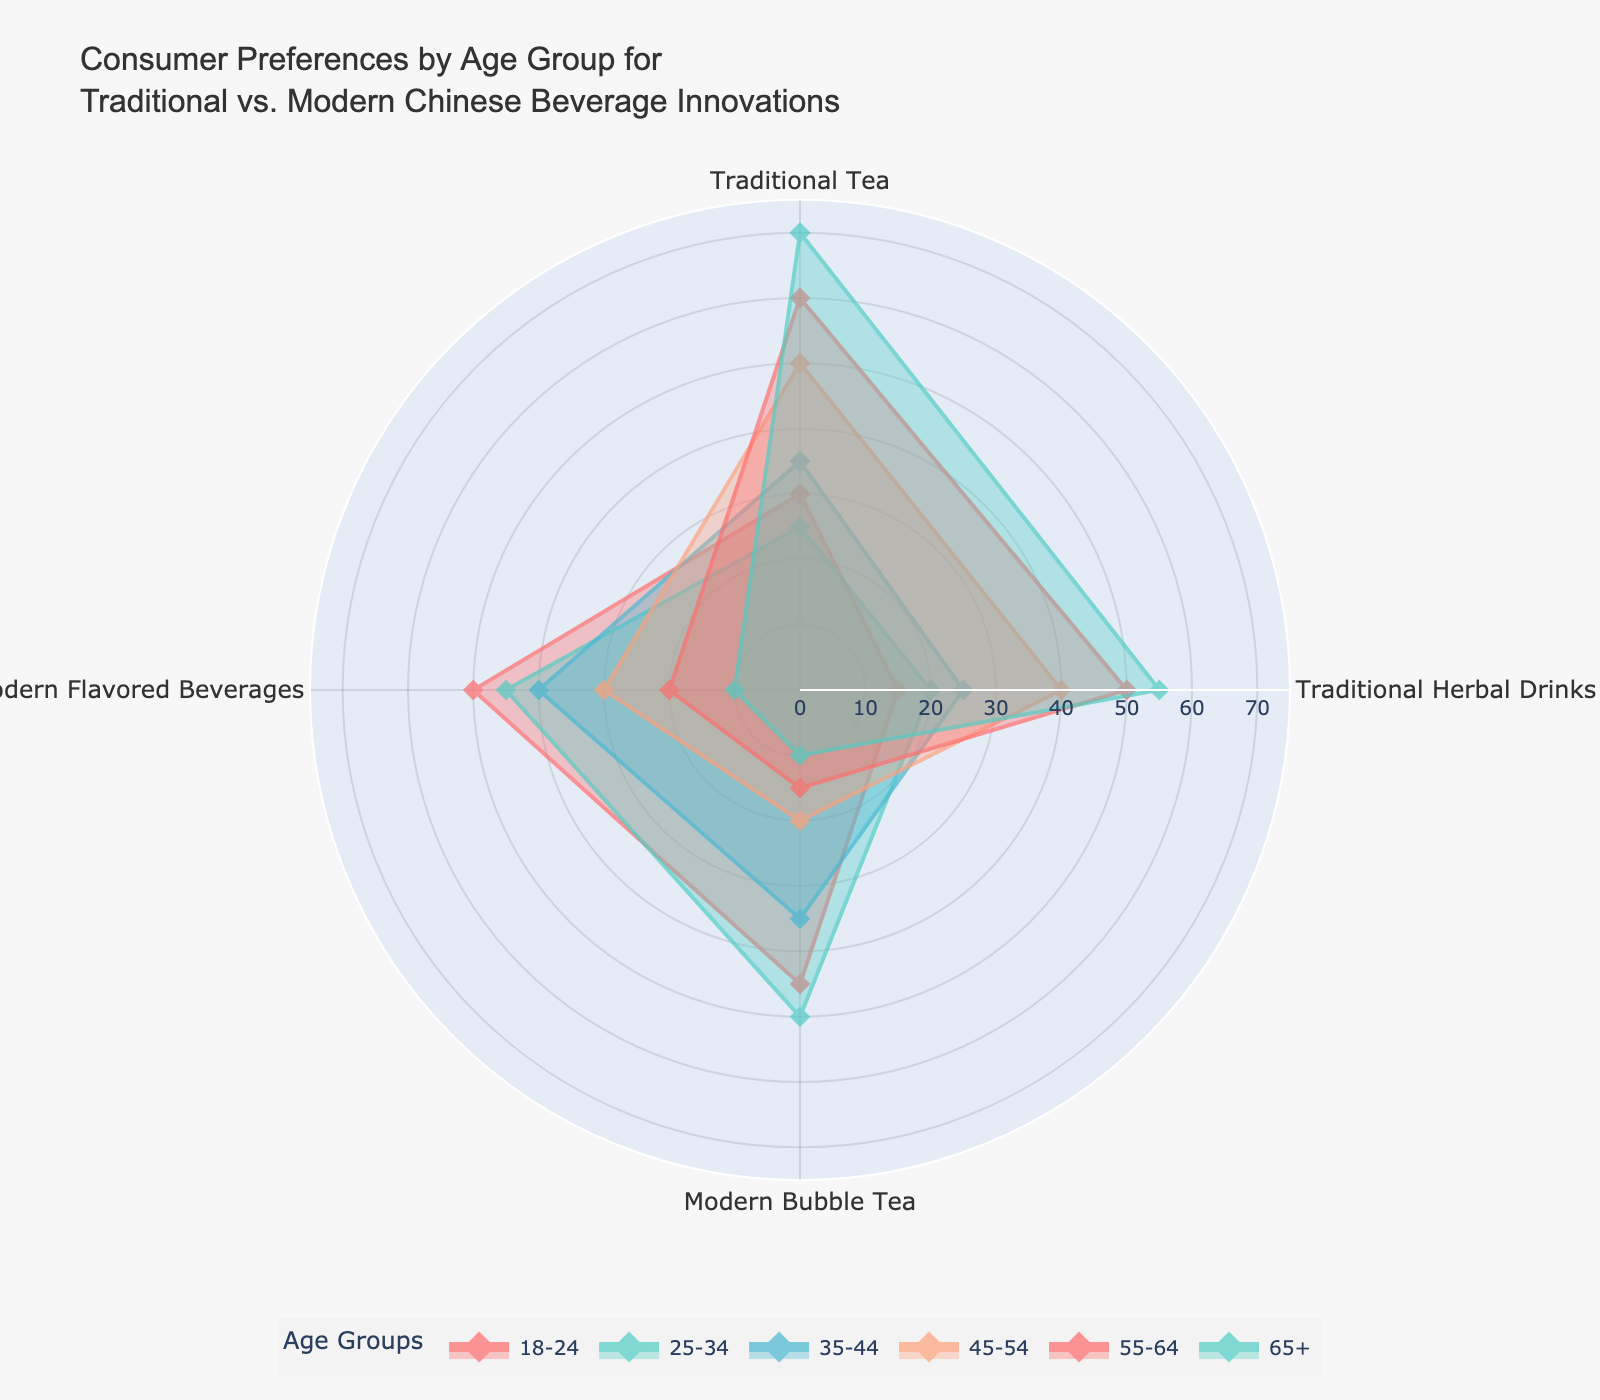What's the most preferred beverage for the 18-24 age group? By looking at the radar chart, we can see that the largest value for the 18-24 age group is for "Modern Flavored Beverages" with a value of 50.
Answer: Modern Flavored Beverages Which age group prefers Traditional Tea the most? Observing the chart, the highest value for Traditional Tea lies with the age group "65+" having a preference value of 70.
Answer: 65+ What is the least preferred beverage for the 25-34 age group? For the age group 25-34, the radar chart shows that the lowest value is in "Traditional Tea" with a value of 25.
Answer: Traditional Tea How does the 45-54 age group compare between Traditional Herbal Drinks and Modern Bubble Tea? In the radar chart, for the 45-54 age group, Traditional Herbal Drinks have a value of 40 while Modern Bubble Tea has a value of 20, indicating that Traditional Herbal Drinks are preferred twice as much.
Answer: Traditional Herbal Drinks are twice as preferred Which age group shows the highest preference for Modern Bubble Tea? The radar chart reveals that the 25-34 age group has the highest preference for Modern Bubble Tea with a value of 50.
Answer: 25-34 What is the overall trend of preference for Traditional Tea as age increases? By analyzing the values for Traditional Tea across age groups in the radar chart, we can observe that the preference steadily increases from 30 in the 18-24 age group to 70 in the 65+ age group.
Answer: Increases steadily Which is more preferred by the 55-64 age group: Modern Flavored Beverages or Traditional Herbal Drinks? According to the radar chart, the 55-64 age group has a preference of 20 for Modern Flavored Beverages and 50 for Traditional Herbal Drinks, indicating that Traditional Herbal Drinks are much more preferred.
Answer: Traditional Herbal Drinks Compare the preference for Modern Bubble Tea between the 35-44 and 18-24 age groups. The radar chart shows that the 35-44 age group has a preference of 35 for Modern Bubble Tea while the 18-24 age group has a higher preference of 45.
Answer: 18-24 has a higher preference What's the range of preference values for Traditional Herbal Drinks across all age groups? Looking at the radar chart, the values for Traditional Herbal Drinks range from 15 in the 18-24 age group to 55 in the 65+ age group.
Answer: 15 to 55 Which age group has the closest preference between Traditional Tea and Modern Flavored Beverages? By comparing the radar values, the 45-54 age group shows values of 50 for Traditional Tea and 30 for Modern Flavored Beverages, which are the closest when considering the overall pattern.
Answer: 45-54 